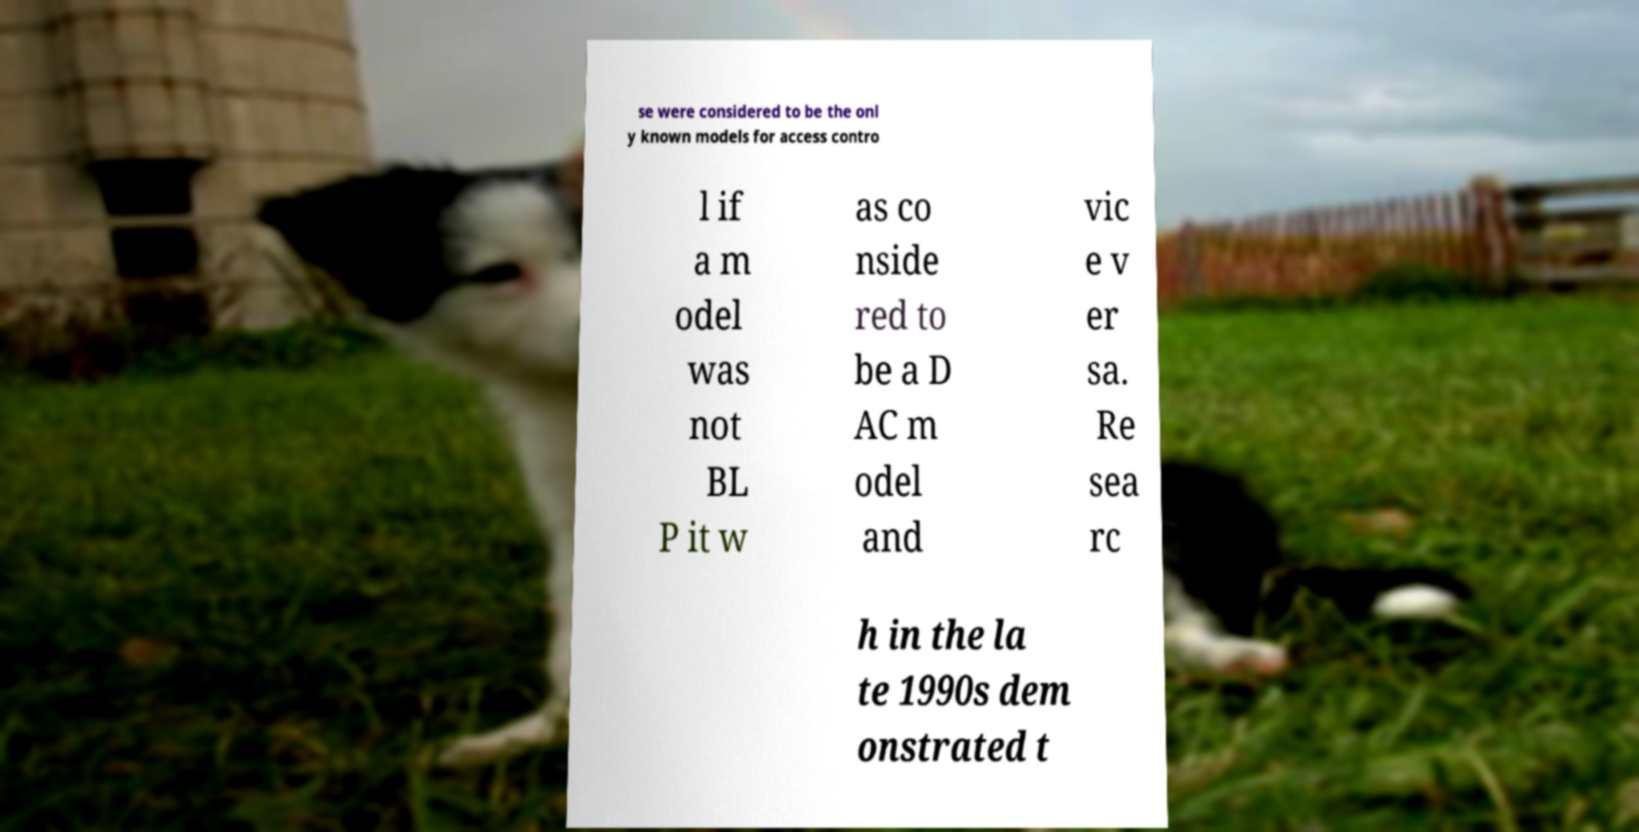Please read and relay the text visible in this image. What does it say? se were considered to be the onl y known models for access contro l if a m odel was not BL P it w as co nside red to be a D AC m odel and vic e v er sa. Re sea rc h in the la te 1990s dem onstrated t 